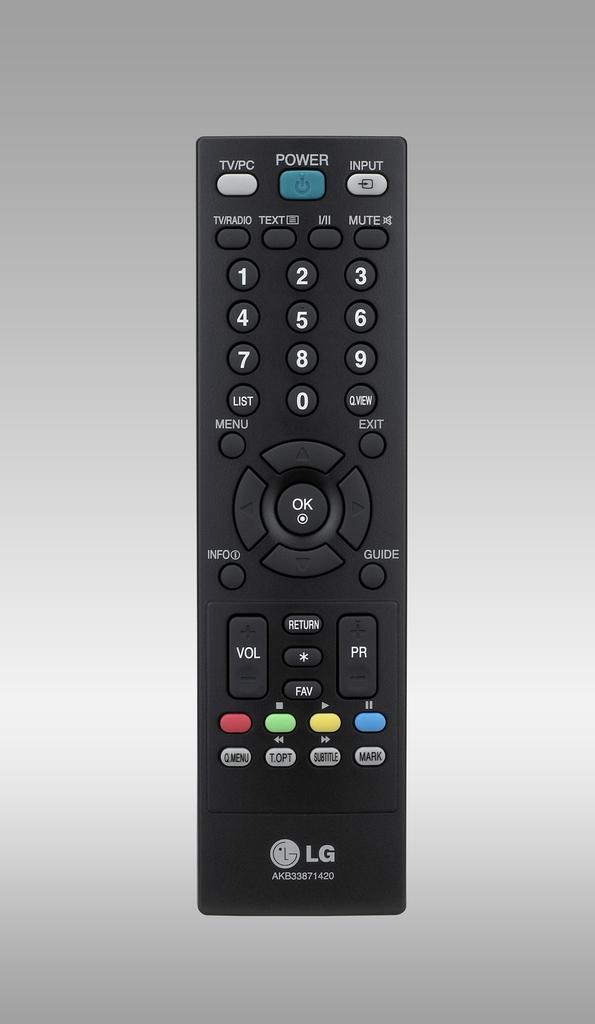Name the brand of remote?
Provide a short and direct response. Lg. 